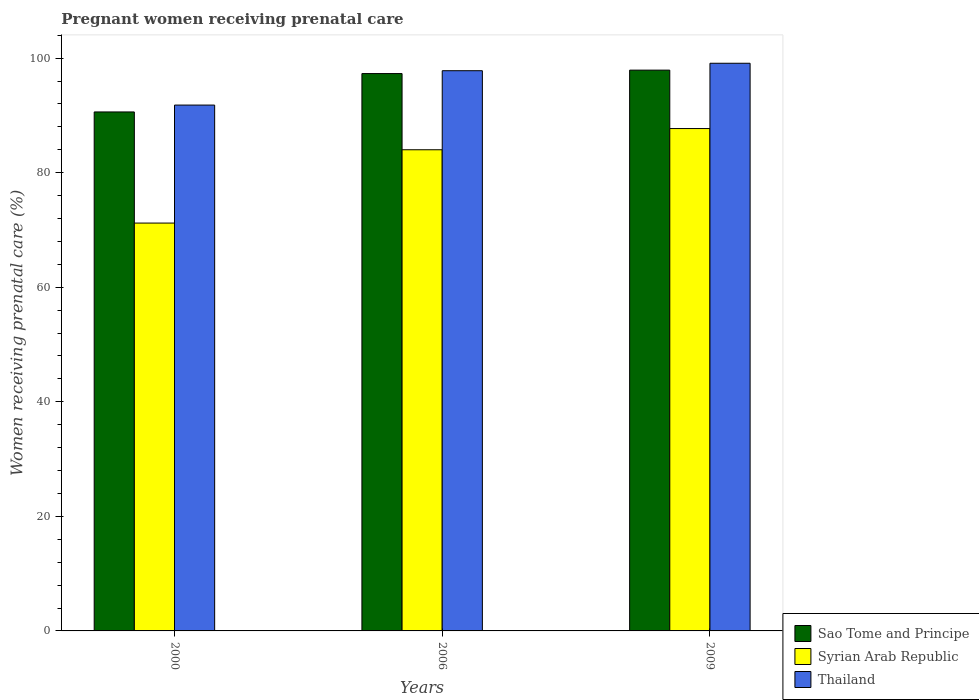How many bars are there on the 2nd tick from the left?
Provide a succinct answer. 3. How many bars are there on the 1st tick from the right?
Provide a short and direct response. 3. What is the label of the 1st group of bars from the left?
Make the answer very short. 2000. In how many cases, is the number of bars for a given year not equal to the number of legend labels?
Offer a terse response. 0. What is the percentage of women receiving prenatal care in Syrian Arab Republic in 2000?
Your response must be concise. 71.2. Across all years, what is the maximum percentage of women receiving prenatal care in Thailand?
Offer a terse response. 99.1. Across all years, what is the minimum percentage of women receiving prenatal care in Sao Tome and Principe?
Provide a short and direct response. 90.6. In which year was the percentage of women receiving prenatal care in Syrian Arab Republic maximum?
Your response must be concise. 2009. In which year was the percentage of women receiving prenatal care in Thailand minimum?
Give a very brief answer. 2000. What is the total percentage of women receiving prenatal care in Syrian Arab Republic in the graph?
Give a very brief answer. 242.9. What is the difference between the percentage of women receiving prenatal care in Syrian Arab Republic in 2006 and that in 2009?
Your response must be concise. -3.7. What is the difference between the percentage of women receiving prenatal care in Syrian Arab Republic in 2000 and the percentage of women receiving prenatal care in Thailand in 2009?
Make the answer very short. -27.9. What is the average percentage of women receiving prenatal care in Sao Tome and Principe per year?
Offer a very short reply. 95.27. In the year 2006, what is the difference between the percentage of women receiving prenatal care in Syrian Arab Republic and percentage of women receiving prenatal care in Sao Tome and Principe?
Offer a terse response. -13.3. What is the ratio of the percentage of women receiving prenatal care in Syrian Arab Republic in 2000 to that in 2006?
Give a very brief answer. 0.85. Is the difference between the percentage of women receiving prenatal care in Syrian Arab Republic in 2000 and 2009 greater than the difference between the percentage of women receiving prenatal care in Sao Tome and Principe in 2000 and 2009?
Give a very brief answer. No. What is the difference between the highest and the second highest percentage of women receiving prenatal care in Sao Tome and Principe?
Provide a succinct answer. 0.6. What is the difference between the highest and the lowest percentage of women receiving prenatal care in Thailand?
Your answer should be compact. 7.3. What does the 3rd bar from the left in 2000 represents?
Provide a succinct answer. Thailand. What does the 2nd bar from the right in 2009 represents?
Your response must be concise. Syrian Arab Republic. How many bars are there?
Offer a very short reply. 9. Are all the bars in the graph horizontal?
Offer a very short reply. No. How many years are there in the graph?
Provide a short and direct response. 3. Are the values on the major ticks of Y-axis written in scientific E-notation?
Offer a terse response. No. Does the graph contain grids?
Offer a terse response. No. Where does the legend appear in the graph?
Your response must be concise. Bottom right. How many legend labels are there?
Provide a short and direct response. 3. What is the title of the graph?
Make the answer very short. Pregnant women receiving prenatal care. Does "Bulgaria" appear as one of the legend labels in the graph?
Offer a very short reply. No. What is the label or title of the Y-axis?
Give a very brief answer. Women receiving prenatal care (%). What is the Women receiving prenatal care (%) of Sao Tome and Principe in 2000?
Ensure brevity in your answer.  90.6. What is the Women receiving prenatal care (%) in Syrian Arab Republic in 2000?
Offer a very short reply. 71.2. What is the Women receiving prenatal care (%) in Thailand in 2000?
Ensure brevity in your answer.  91.8. What is the Women receiving prenatal care (%) in Sao Tome and Principe in 2006?
Keep it short and to the point. 97.3. What is the Women receiving prenatal care (%) in Syrian Arab Republic in 2006?
Provide a succinct answer. 84. What is the Women receiving prenatal care (%) of Thailand in 2006?
Your answer should be compact. 97.8. What is the Women receiving prenatal care (%) of Sao Tome and Principe in 2009?
Ensure brevity in your answer.  97.9. What is the Women receiving prenatal care (%) in Syrian Arab Republic in 2009?
Provide a short and direct response. 87.7. What is the Women receiving prenatal care (%) of Thailand in 2009?
Offer a terse response. 99.1. Across all years, what is the maximum Women receiving prenatal care (%) in Sao Tome and Principe?
Provide a short and direct response. 97.9. Across all years, what is the maximum Women receiving prenatal care (%) in Syrian Arab Republic?
Provide a succinct answer. 87.7. Across all years, what is the maximum Women receiving prenatal care (%) in Thailand?
Your response must be concise. 99.1. Across all years, what is the minimum Women receiving prenatal care (%) in Sao Tome and Principe?
Make the answer very short. 90.6. Across all years, what is the minimum Women receiving prenatal care (%) of Syrian Arab Republic?
Provide a succinct answer. 71.2. Across all years, what is the minimum Women receiving prenatal care (%) in Thailand?
Your answer should be compact. 91.8. What is the total Women receiving prenatal care (%) in Sao Tome and Principe in the graph?
Your answer should be very brief. 285.8. What is the total Women receiving prenatal care (%) of Syrian Arab Republic in the graph?
Keep it short and to the point. 242.9. What is the total Women receiving prenatal care (%) of Thailand in the graph?
Offer a terse response. 288.7. What is the difference between the Women receiving prenatal care (%) of Sao Tome and Principe in 2000 and that in 2006?
Your answer should be very brief. -6.7. What is the difference between the Women receiving prenatal care (%) of Syrian Arab Republic in 2000 and that in 2006?
Provide a succinct answer. -12.8. What is the difference between the Women receiving prenatal care (%) in Thailand in 2000 and that in 2006?
Give a very brief answer. -6. What is the difference between the Women receiving prenatal care (%) in Sao Tome and Principe in 2000 and that in 2009?
Offer a terse response. -7.3. What is the difference between the Women receiving prenatal care (%) in Syrian Arab Republic in 2000 and that in 2009?
Your response must be concise. -16.5. What is the difference between the Women receiving prenatal care (%) in Sao Tome and Principe in 2006 and that in 2009?
Offer a terse response. -0.6. What is the difference between the Women receiving prenatal care (%) in Sao Tome and Principe in 2000 and the Women receiving prenatal care (%) in Syrian Arab Republic in 2006?
Provide a short and direct response. 6.6. What is the difference between the Women receiving prenatal care (%) in Syrian Arab Republic in 2000 and the Women receiving prenatal care (%) in Thailand in 2006?
Ensure brevity in your answer.  -26.6. What is the difference between the Women receiving prenatal care (%) of Sao Tome and Principe in 2000 and the Women receiving prenatal care (%) of Syrian Arab Republic in 2009?
Give a very brief answer. 2.9. What is the difference between the Women receiving prenatal care (%) in Syrian Arab Republic in 2000 and the Women receiving prenatal care (%) in Thailand in 2009?
Your response must be concise. -27.9. What is the difference between the Women receiving prenatal care (%) of Sao Tome and Principe in 2006 and the Women receiving prenatal care (%) of Syrian Arab Republic in 2009?
Give a very brief answer. 9.6. What is the difference between the Women receiving prenatal care (%) in Syrian Arab Republic in 2006 and the Women receiving prenatal care (%) in Thailand in 2009?
Provide a succinct answer. -15.1. What is the average Women receiving prenatal care (%) of Sao Tome and Principe per year?
Keep it short and to the point. 95.27. What is the average Women receiving prenatal care (%) in Syrian Arab Republic per year?
Provide a succinct answer. 80.97. What is the average Women receiving prenatal care (%) in Thailand per year?
Make the answer very short. 96.23. In the year 2000, what is the difference between the Women receiving prenatal care (%) in Syrian Arab Republic and Women receiving prenatal care (%) in Thailand?
Keep it short and to the point. -20.6. In the year 2006, what is the difference between the Women receiving prenatal care (%) in Sao Tome and Principe and Women receiving prenatal care (%) in Syrian Arab Republic?
Make the answer very short. 13.3. In the year 2006, what is the difference between the Women receiving prenatal care (%) of Syrian Arab Republic and Women receiving prenatal care (%) of Thailand?
Provide a succinct answer. -13.8. In the year 2009, what is the difference between the Women receiving prenatal care (%) in Sao Tome and Principe and Women receiving prenatal care (%) in Syrian Arab Republic?
Offer a terse response. 10.2. In the year 2009, what is the difference between the Women receiving prenatal care (%) of Sao Tome and Principe and Women receiving prenatal care (%) of Thailand?
Give a very brief answer. -1.2. In the year 2009, what is the difference between the Women receiving prenatal care (%) in Syrian Arab Republic and Women receiving prenatal care (%) in Thailand?
Give a very brief answer. -11.4. What is the ratio of the Women receiving prenatal care (%) of Sao Tome and Principe in 2000 to that in 2006?
Provide a short and direct response. 0.93. What is the ratio of the Women receiving prenatal care (%) in Syrian Arab Republic in 2000 to that in 2006?
Your answer should be compact. 0.85. What is the ratio of the Women receiving prenatal care (%) of Thailand in 2000 to that in 2006?
Give a very brief answer. 0.94. What is the ratio of the Women receiving prenatal care (%) of Sao Tome and Principe in 2000 to that in 2009?
Your answer should be compact. 0.93. What is the ratio of the Women receiving prenatal care (%) of Syrian Arab Republic in 2000 to that in 2009?
Offer a terse response. 0.81. What is the ratio of the Women receiving prenatal care (%) in Thailand in 2000 to that in 2009?
Keep it short and to the point. 0.93. What is the ratio of the Women receiving prenatal care (%) in Sao Tome and Principe in 2006 to that in 2009?
Your answer should be compact. 0.99. What is the ratio of the Women receiving prenatal care (%) in Syrian Arab Republic in 2006 to that in 2009?
Your answer should be compact. 0.96. What is the ratio of the Women receiving prenatal care (%) of Thailand in 2006 to that in 2009?
Provide a short and direct response. 0.99. What is the difference between the highest and the lowest Women receiving prenatal care (%) of Sao Tome and Principe?
Offer a very short reply. 7.3. What is the difference between the highest and the lowest Women receiving prenatal care (%) of Syrian Arab Republic?
Make the answer very short. 16.5. 